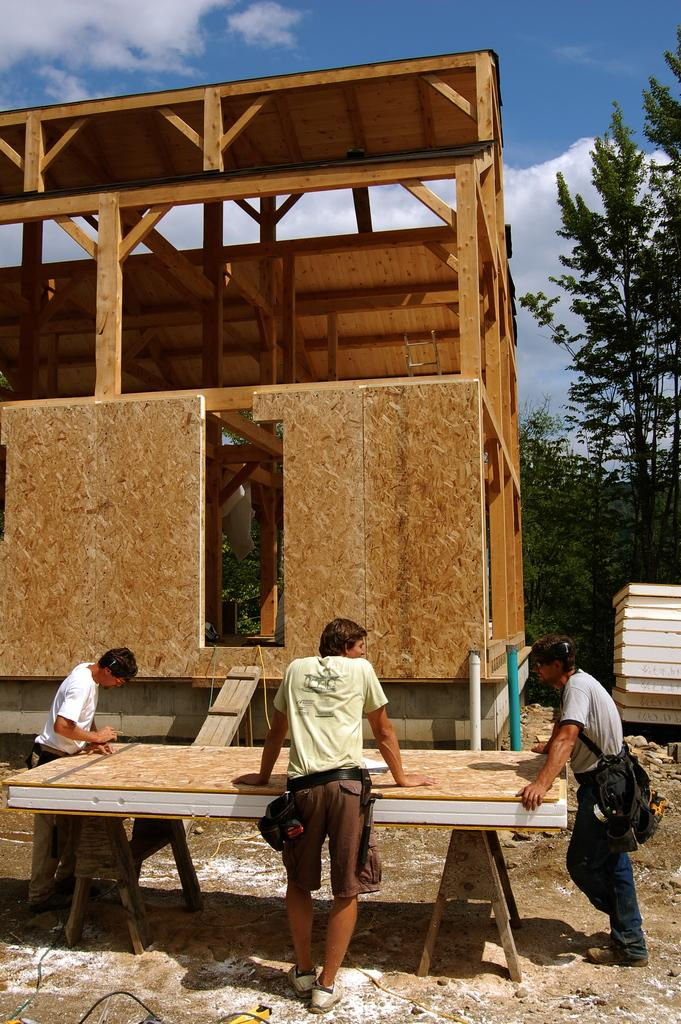How many people are present in the image? There are three persons standing in the image. What can be seen in the image besides the people? There is an unspecified "thing" in the image. What type of objects can be seen in the background of the image? There are wooden objects and trees in the background of the image. What is visible in the sky in the image? The sky is visible in the background of the image. What type of agreement is being signed by the persons in the image? There is no indication in the image that the persons are signing any agreement. 